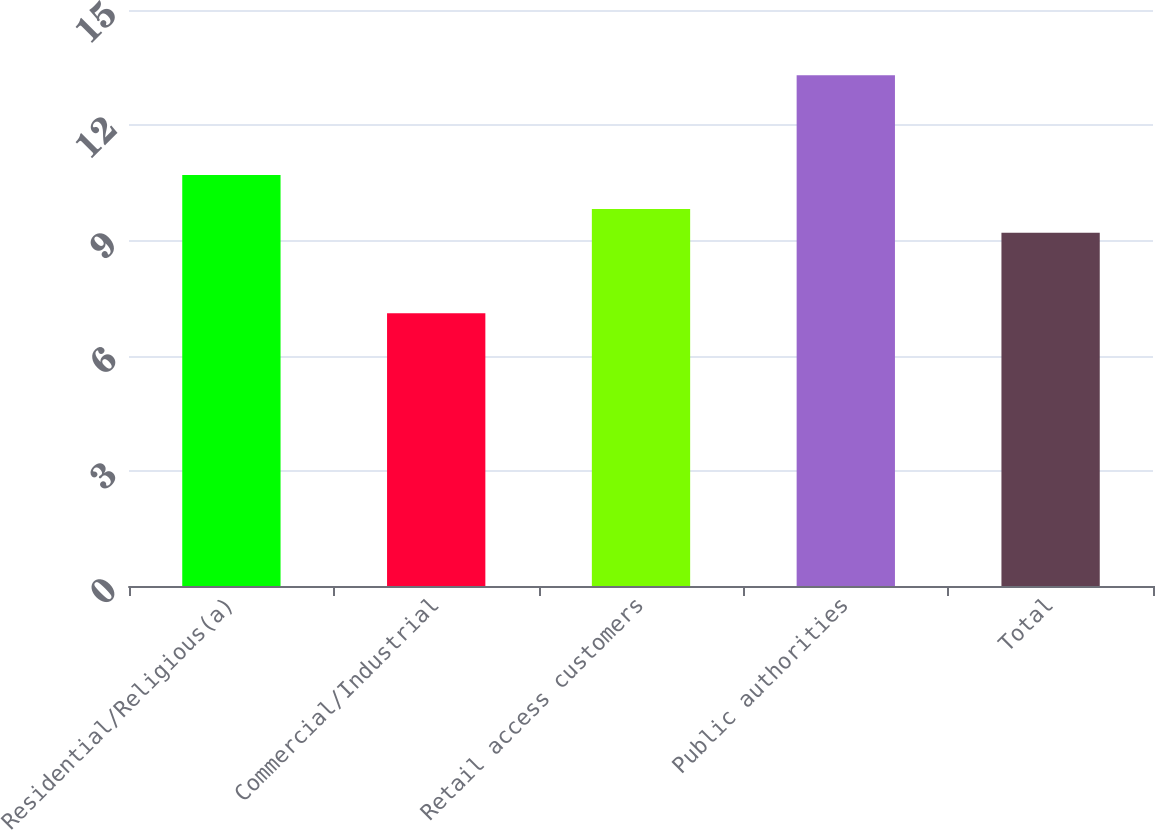Convert chart to OTSL. <chart><loc_0><loc_0><loc_500><loc_500><bar_chart><fcel>Residential/Religious(a)<fcel>Commercial/Industrial<fcel>Retail access customers<fcel>Public authorities<fcel>Total<nl><fcel>10.7<fcel>7.1<fcel>9.82<fcel>13.3<fcel>9.2<nl></chart> 